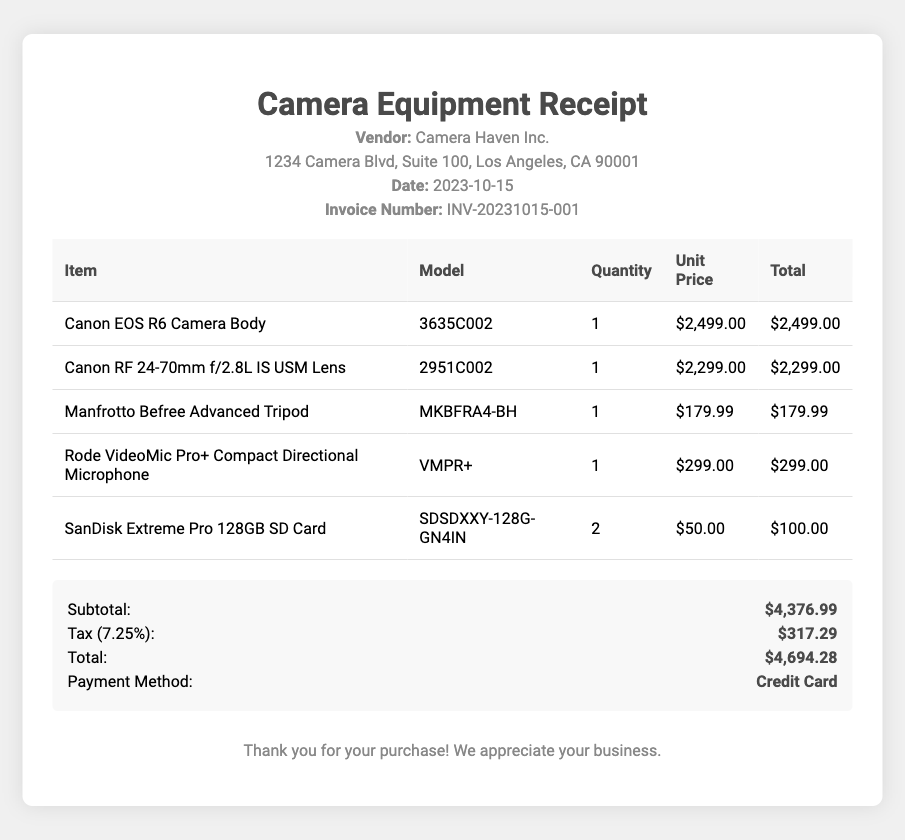What is the vendor's name? The vendor's name is mentioned at the top of the document under "Vendor," which states "Camera Haven Inc."
Answer: Camera Haven Inc What is the invoice number? The invoice number can be found in the header section of the document, specifically labeled as "Invoice Number."
Answer: INV-20231015-001 What is the total cost? The total cost is summarized in the document under "Total," which is the final amount stated after taxes and other calculations.
Answer: $4,694.28 How many SanDisk Extreme Pro 128GB SD Cards were purchased? The quantity of SanDisk Extreme Pro 128GB SD Cards is provided in the table under the "Quantity" column next to the corresponding item.
Answer: 2 What is the unit price of the Rode VideoMic Pro+? The unit price is listed in the table under the "Unit Price" column next to the Rode VideoMic Pro+ item.
Answer: $299.00 What is the subtotal amount before tax? The subtotal amount is noted in the document under "Subtotal," which is the sum of the items' total prices before the addition of tax.
Answer: $4,376.99 What is the total tax amount applied? The total tax amount can be found in the summary section listed under "Tax," which is calculated based on the subtotal.
Answer: $317.29 What type of payment method was used? The payment method is specified in the summary section, labeled as "Payment Method."
Answer: Credit Card What is the date of purchase? The date of purchase is recorded in the document under "Date" in the header section.
Answer: 2023-10-15 